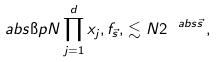Convert formula to latex. <formula><loc_0><loc_0><loc_500><loc_500>\ a b s { \i p N \prod _ { j = 1 } ^ { d } x _ { j } , f _ { \vec { s } } , } \lesssim N 2 ^ { \ a b s { \vec { s } } } \, ,</formula> 